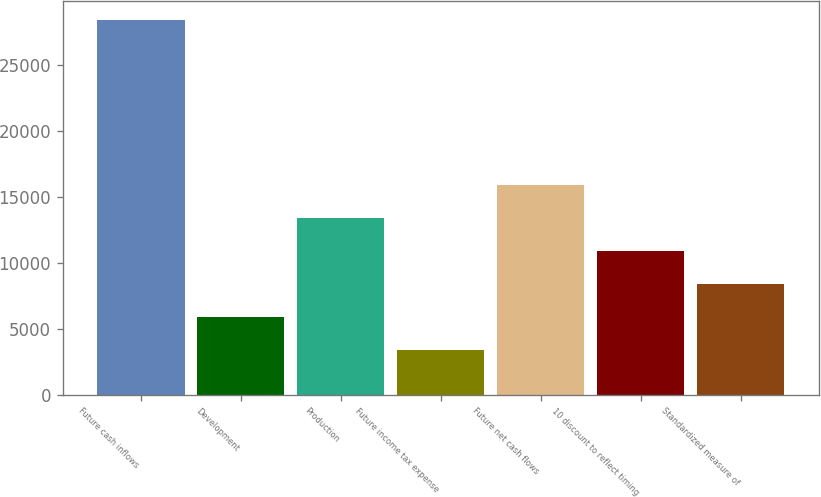Convert chart to OTSL. <chart><loc_0><loc_0><loc_500><loc_500><bar_chart><fcel>Future cash inflows<fcel>Development<fcel>Production<fcel>Future income tax expense<fcel>Future net cash flows<fcel>10 discount to reflect timing<fcel>Standardized measure of<nl><fcel>28442<fcel>5911.4<fcel>13421.6<fcel>3408<fcel>15925<fcel>10918.2<fcel>8414.8<nl></chart> 